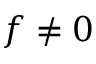Convert formula to latex. <formula><loc_0><loc_0><loc_500><loc_500>f \neq 0</formula> 